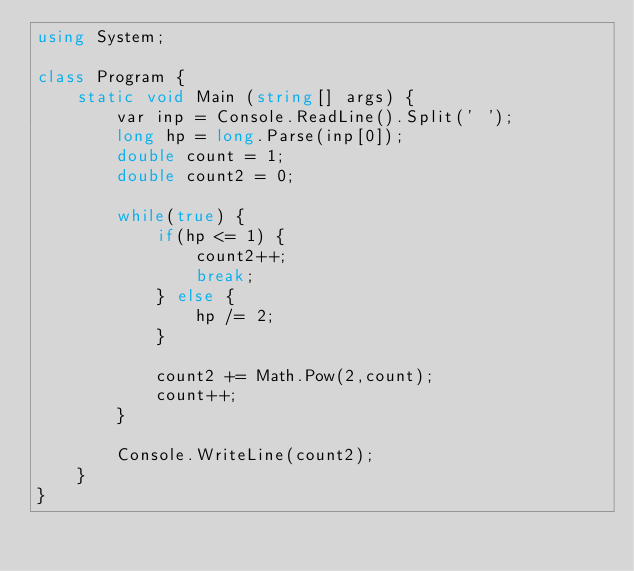Convert code to text. <code><loc_0><loc_0><loc_500><loc_500><_C#_>using System;

class Program {
    static void Main (string[] args) {
        var inp = Console.ReadLine().Split(' ');
        long hp = long.Parse(inp[0]);
        double count = 1;
        double count2 = 0;

        while(true) {
            if(hp <= 1) {
                count2++;
                break;
            } else {
                hp /= 2;
            }

            count2 += Math.Pow(2,count);
            count++;
        }

        Console.WriteLine(count2);
    }
}</code> 